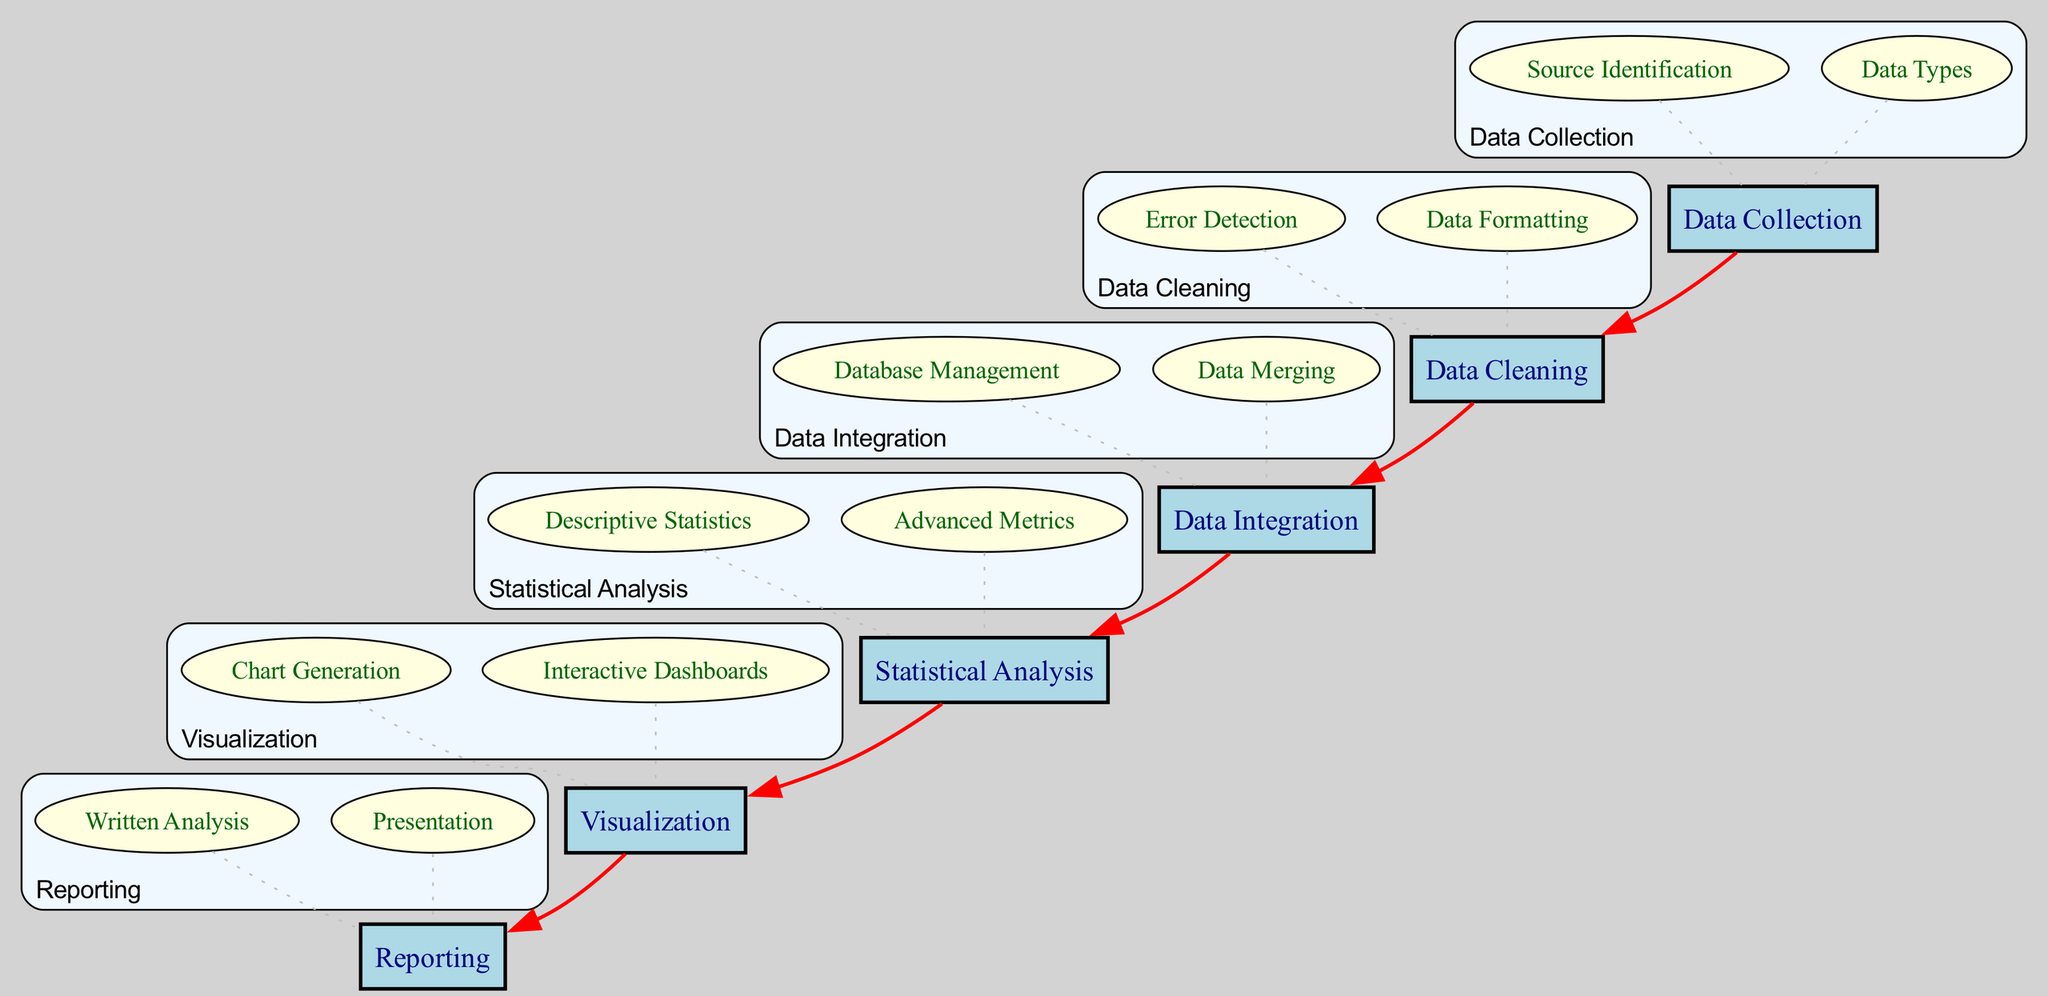What is the first step in the workflow? The first step in the workflow is "Data Collection," which is indicated at the top of the flow chart as the initial node.
Answer: Data Collection How many main workflow elements are there? The diagram shows six main workflow elements, each representing a distinct phase in the advanced statistics implementation process.
Answer: Six What connects "Data Cleaning" to "Data Integration"? "Data Cleaning" is connected to "Data Integration" with a red edge indicating the flow from one phase to the next in the workflow, showing the sequence of operations.
Answer: A red edge What type of statistics is calculated in the "Statistical Analysis" phase? The "Statistical Analysis" phase encompasses both descriptive statistics and advanced metrics including Corsi and Expected Goals, highlighted as subelements under this main element.
Answer: Advanced Metrics How many subelements are under "Visualization"? The "Visualization" main element has two subelements: "Chart Generation" and "Interactive Dashboards," clearly indicated under the visualization box.
Answer: Two Which element follows "Data Integration" in the workflow? "Statistical Analysis" follows "Data Integration" in the workflow, as shown by the connecting edge directing from the former to the latter.
Answer: Statistical Analysis Identify the main focus of the "Reporting" stage. The main focus of the "Reporting" stage is to compile results into a comprehensive report for stakeholders, which consists of written analysis and presentation as subelements.
Answer: Results compilation What color are the subelements depicted in the diagram? The subelements are represented in a light yellow color, differentiating them from the main elements which are in light blue.
Answer: Light yellow What type of edge is used to link subelements to their main element? A dotted gray edge is used to connect each subelement back to its respective main element, visually indicating their relationship in the workflow.
Answer: Dotted gray edge 